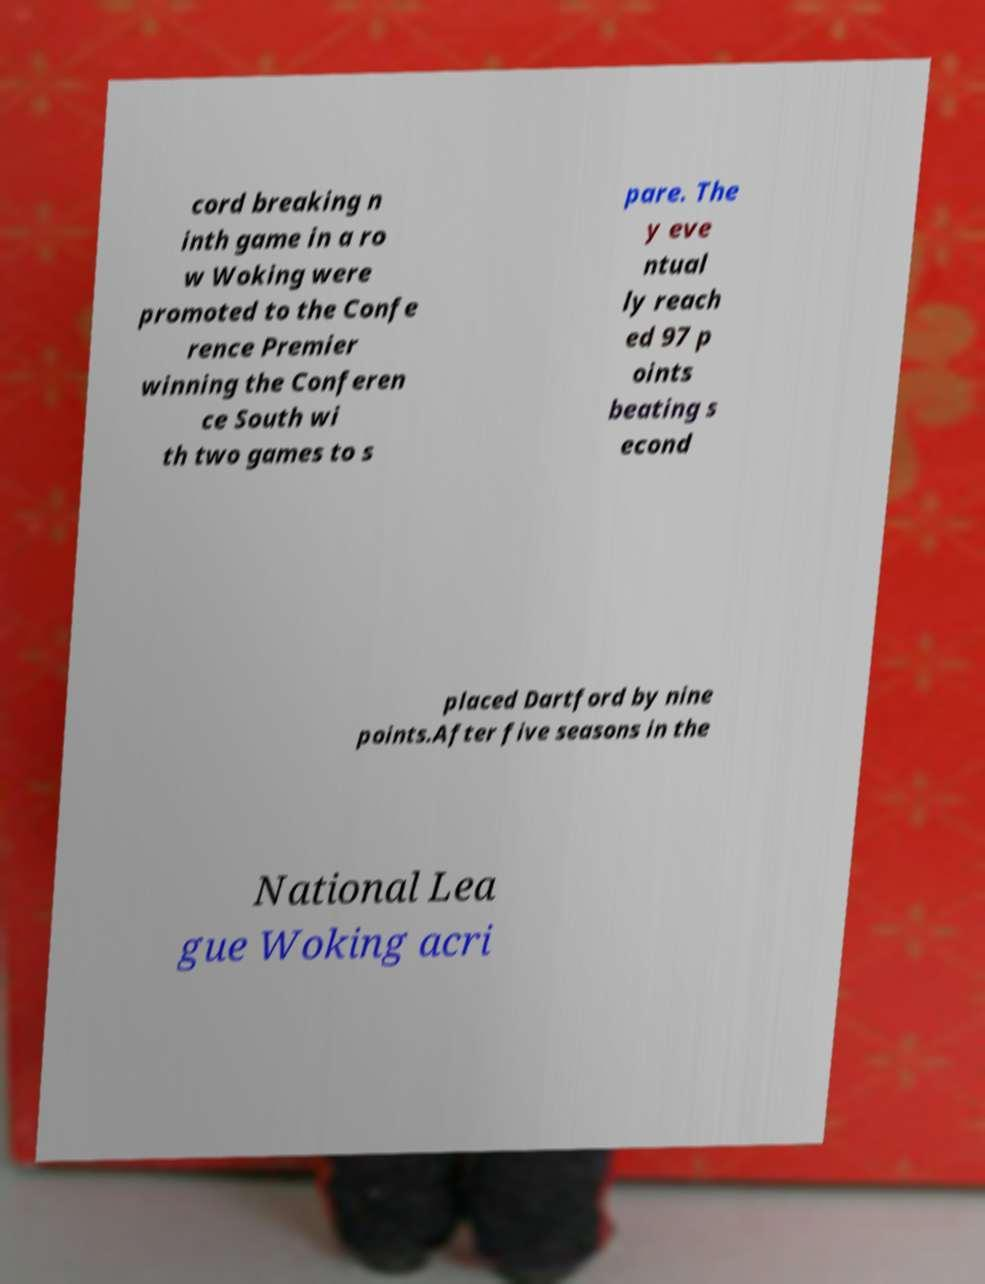What messages or text are displayed in this image? I need them in a readable, typed format. cord breaking n inth game in a ro w Woking were promoted to the Confe rence Premier winning the Conferen ce South wi th two games to s pare. The y eve ntual ly reach ed 97 p oints beating s econd placed Dartford by nine points.After five seasons in the National Lea gue Woking acri 